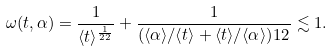<formula> <loc_0><loc_0><loc_500><loc_500>\omega ( t , \alpha ) = \frac { 1 } { \langle t \rangle ^ { \frac { 1 } { 2 2 } } } + \frac { 1 } { ( \langle \alpha \rangle / \langle t \rangle + \langle t \rangle / \langle \alpha \rangle ) ^ { } { 1 } 2 } \lesssim 1 .</formula> 